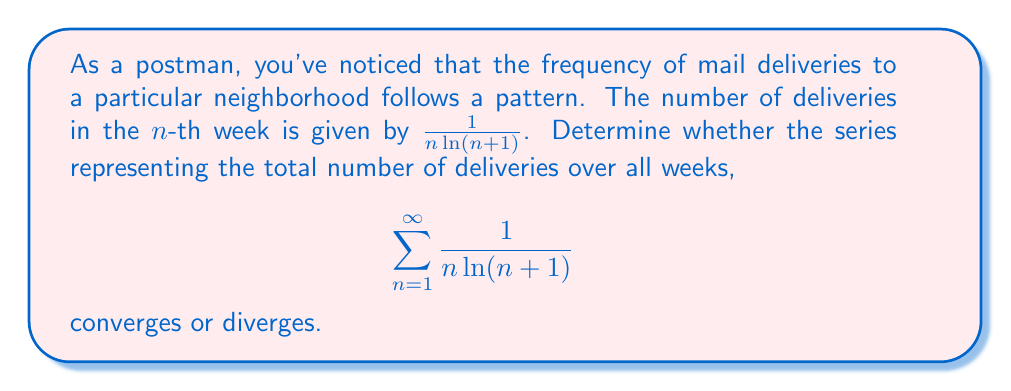Could you help me with this problem? To determine the convergence of this series, we can use the integral test. Let's define $f(x) = \frac{1}{x\ln(x+1)}$ for $x \geq 1$.

1) First, we need to verify that $f(x)$ is continuous, positive, and decreasing on $[1,\infty)$:
   - $f(x)$ is continuous for $x \geq 1$
   - $f(x) > 0$ for all $x \geq 1$
   - $f'(x) = -\frac{\ln(x+1) + 1}{x^2(\ln(x+1))^2} < 0$ for $x \geq 1$, so $f(x)$ is decreasing

2) Now, we can apply the integral test. The series converges if and only if the improper integral converges:

   $$\int_1^{\infty} \frac{1}{x\ln(x+1)} dx$$

3) To evaluate this integral, let's use the substitution $u = \ln(x+1)$:
   
   $x = e^u - 1$
   $dx = e^u du$

4) Substituting:

   $$\int_1^{\infty} \frac{1}{x\ln(x+1)} dx = \int_{\ln 2}^{\infty} \frac{1}{(e^u-1)u} \cdot e^u du = \int_{\ln 2}^{\infty} \frac{1}{u(e^u-1)} \cdot e^u du = \int_{\ln 2}^{\infty} \frac{1}{u} du$$

5) The last integral is the natural logarithm function:

   $$\int_{\ln 2}^{\infty} \frac{1}{u} du = \lim_{b\to\infty} [\ln u]_{\ln 2}^b = \lim_{b\to\infty} (\ln b - \ln(\ln 2))$$

6) As $b$ approaches infinity, this limit diverges to infinity.

Therefore, the improper integral diverges, which means the original series also diverges.
Answer: The series $\sum_{n=1}^{\infty} \frac{1}{n\ln(n+1)}$ diverges. 